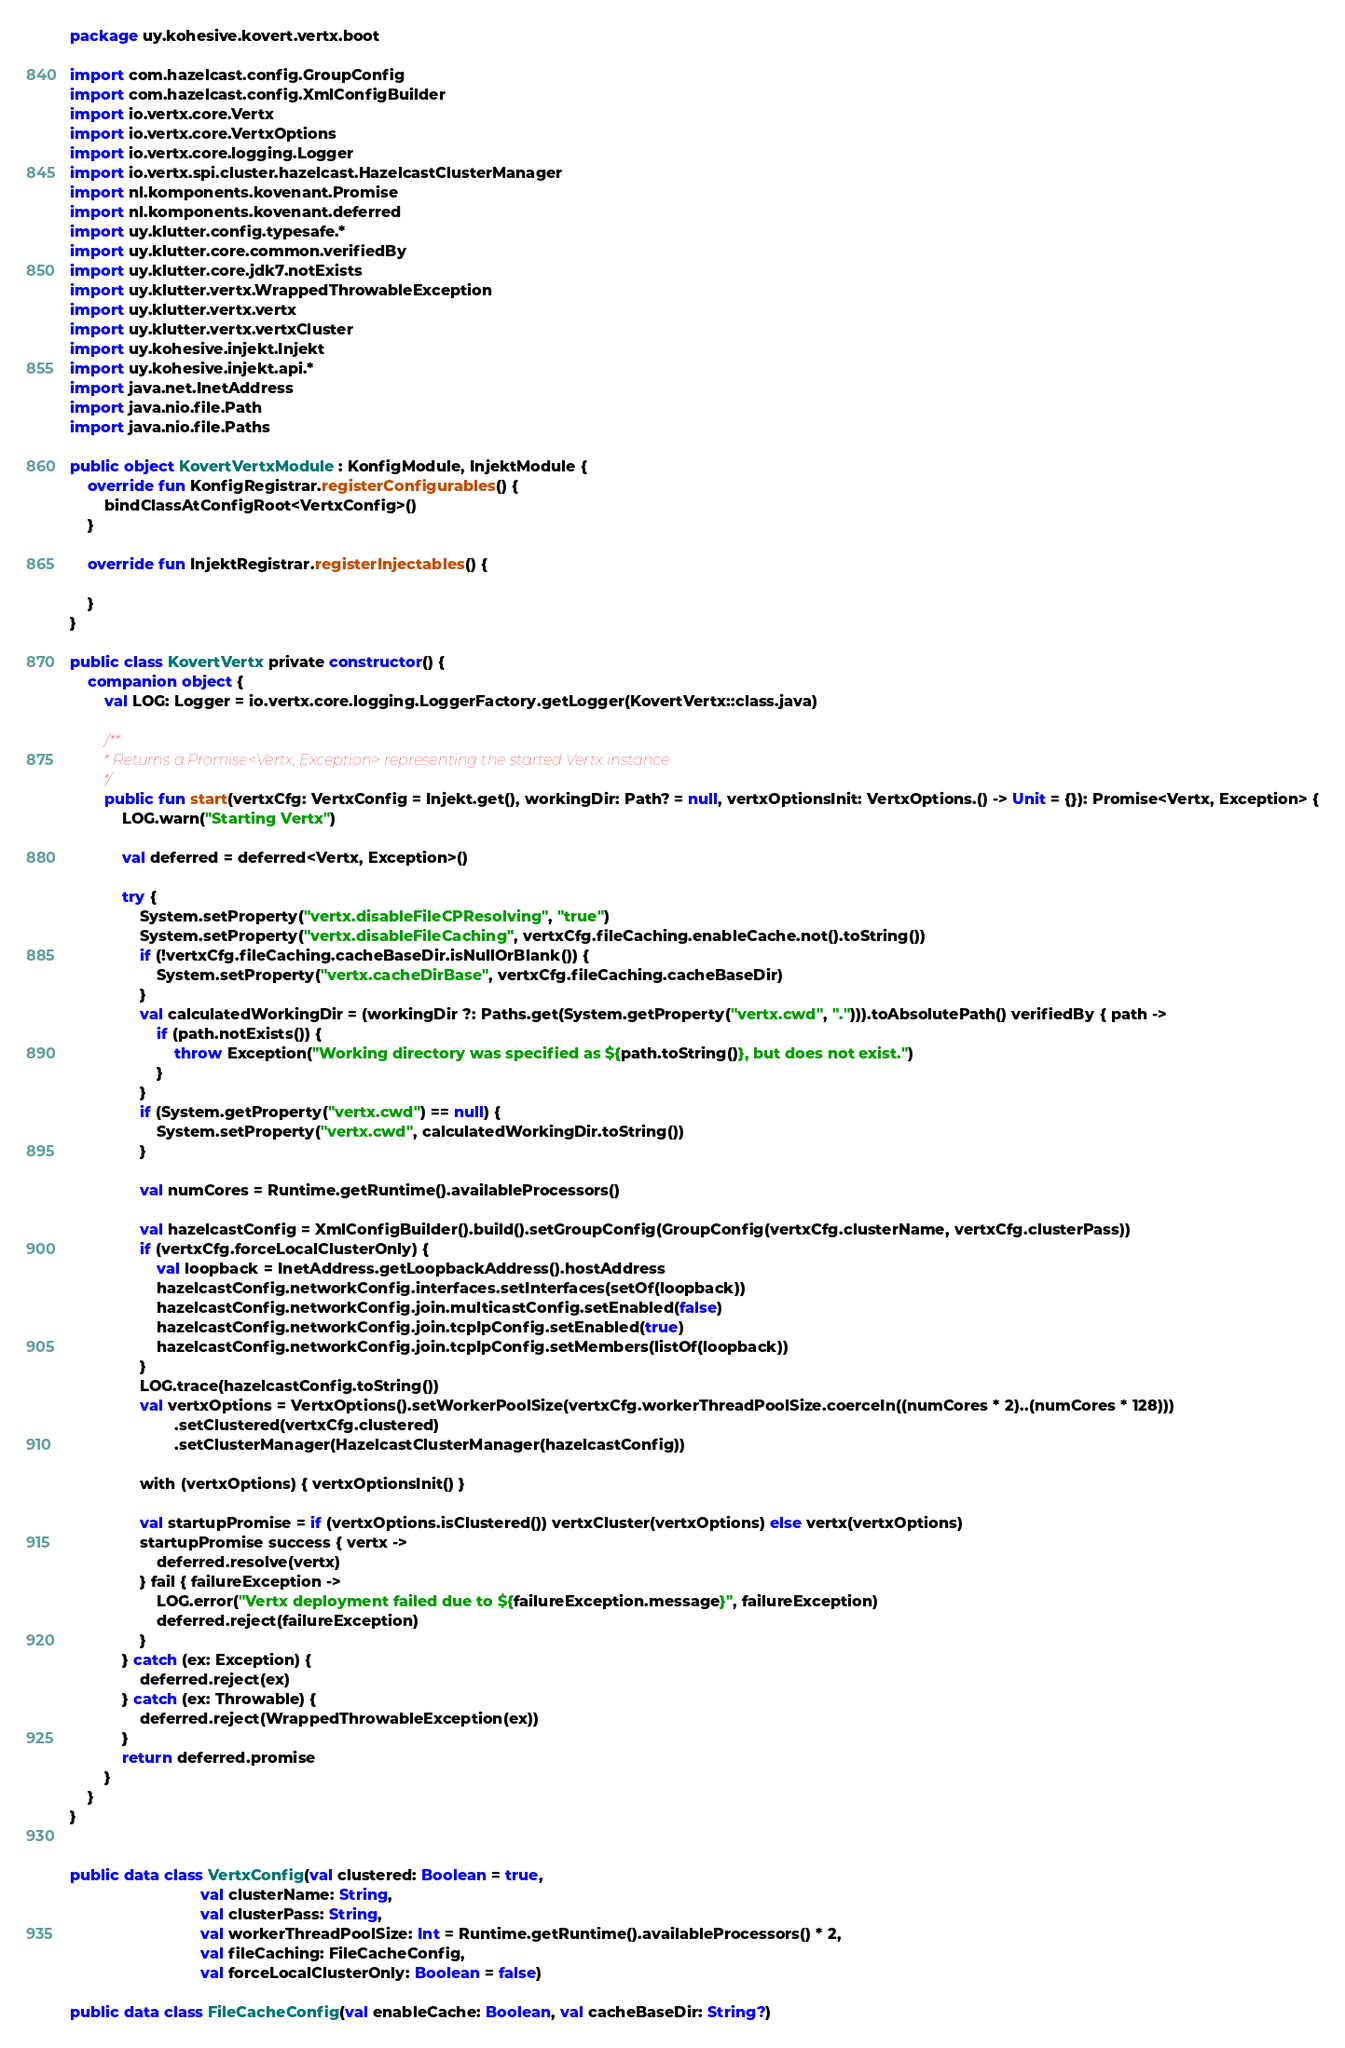<code> <loc_0><loc_0><loc_500><loc_500><_Kotlin_>package uy.kohesive.kovert.vertx.boot

import com.hazelcast.config.GroupConfig
import com.hazelcast.config.XmlConfigBuilder
import io.vertx.core.Vertx
import io.vertx.core.VertxOptions
import io.vertx.core.logging.Logger
import io.vertx.spi.cluster.hazelcast.HazelcastClusterManager
import nl.komponents.kovenant.Promise
import nl.komponents.kovenant.deferred
import uy.klutter.config.typesafe.*
import uy.klutter.core.common.verifiedBy
import uy.klutter.core.jdk7.notExists
import uy.klutter.vertx.WrappedThrowableException
import uy.klutter.vertx.vertx
import uy.klutter.vertx.vertxCluster
import uy.kohesive.injekt.Injekt
import uy.kohesive.injekt.api.*
import java.net.InetAddress
import java.nio.file.Path
import java.nio.file.Paths

public object KovertVertxModule : KonfigModule, InjektModule {
    override fun KonfigRegistrar.registerConfigurables() {
        bindClassAtConfigRoot<VertxConfig>()
    }

    override fun InjektRegistrar.registerInjectables() {

    }
}

public class KovertVertx private constructor() {
    companion object {
        val LOG: Logger = io.vertx.core.logging.LoggerFactory.getLogger(KovertVertx::class.java)

        /**
         * Returns a Promise<Vertx, Exception> representing the started Vertx instance
         */
        public fun start(vertxCfg: VertxConfig = Injekt.get(), workingDir: Path? = null, vertxOptionsInit: VertxOptions.() -> Unit = {}): Promise<Vertx, Exception> {
            LOG.warn("Starting Vertx")

            val deferred = deferred<Vertx, Exception>()

            try {
                System.setProperty("vertx.disableFileCPResolving", "true")
                System.setProperty("vertx.disableFileCaching", vertxCfg.fileCaching.enableCache.not().toString())
                if (!vertxCfg.fileCaching.cacheBaseDir.isNullOrBlank()) {
                    System.setProperty("vertx.cacheDirBase", vertxCfg.fileCaching.cacheBaseDir)
                }
                val calculatedWorkingDir = (workingDir ?: Paths.get(System.getProperty("vertx.cwd", "."))).toAbsolutePath() verifiedBy { path ->
                    if (path.notExists()) {
                        throw Exception("Working directory was specified as ${path.toString()}, but does not exist.")
                    }
                }
                if (System.getProperty("vertx.cwd") == null) {
                    System.setProperty("vertx.cwd", calculatedWorkingDir.toString())
                }

                val numCores = Runtime.getRuntime().availableProcessors()

                val hazelcastConfig = XmlConfigBuilder().build().setGroupConfig(GroupConfig(vertxCfg.clusterName, vertxCfg.clusterPass))
                if (vertxCfg.forceLocalClusterOnly) {
                    val loopback = InetAddress.getLoopbackAddress().hostAddress
                    hazelcastConfig.networkConfig.interfaces.setInterfaces(setOf(loopback))
                    hazelcastConfig.networkConfig.join.multicastConfig.setEnabled(false)
                    hazelcastConfig.networkConfig.join.tcpIpConfig.setEnabled(true)
                    hazelcastConfig.networkConfig.join.tcpIpConfig.setMembers(listOf(loopback))
                }
                LOG.trace(hazelcastConfig.toString())
                val vertxOptions = VertxOptions().setWorkerPoolSize(vertxCfg.workerThreadPoolSize.coerceIn((numCores * 2)..(numCores * 128)))
                        .setClustered(vertxCfg.clustered)
                        .setClusterManager(HazelcastClusterManager(hazelcastConfig))

                with (vertxOptions) { vertxOptionsInit() }

                val startupPromise = if (vertxOptions.isClustered()) vertxCluster(vertxOptions) else vertx(vertxOptions)
                startupPromise success { vertx ->
                    deferred.resolve(vertx)
                } fail { failureException ->
                    LOG.error("Vertx deployment failed due to ${failureException.message}", failureException)
                    deferred.reject(failureException)
                }
            } catch (ex: Exception) {
                deferred.reject(ex)
            } catch (ex: Throwable) {
                deferred.reject(WrappedThrowableException(ex))
            }
            return deferred.promise
        }
    }
}


public data class VertxConfig(val clustered: Boolean = true,
                              val clusterName: String,
                              val clusterPass: String,
                              val workerThreadPoolSize: Int = Runtime.getRuntime().availableProcessors() * 2,
                              val fileCaching: FileCacheConfig,
                              val forceLocalClusterOnly: Boolean = false)

public data class FileCacheConfig(val enableCache: Boolean, val cacheBaseDir: String?)

</code> 